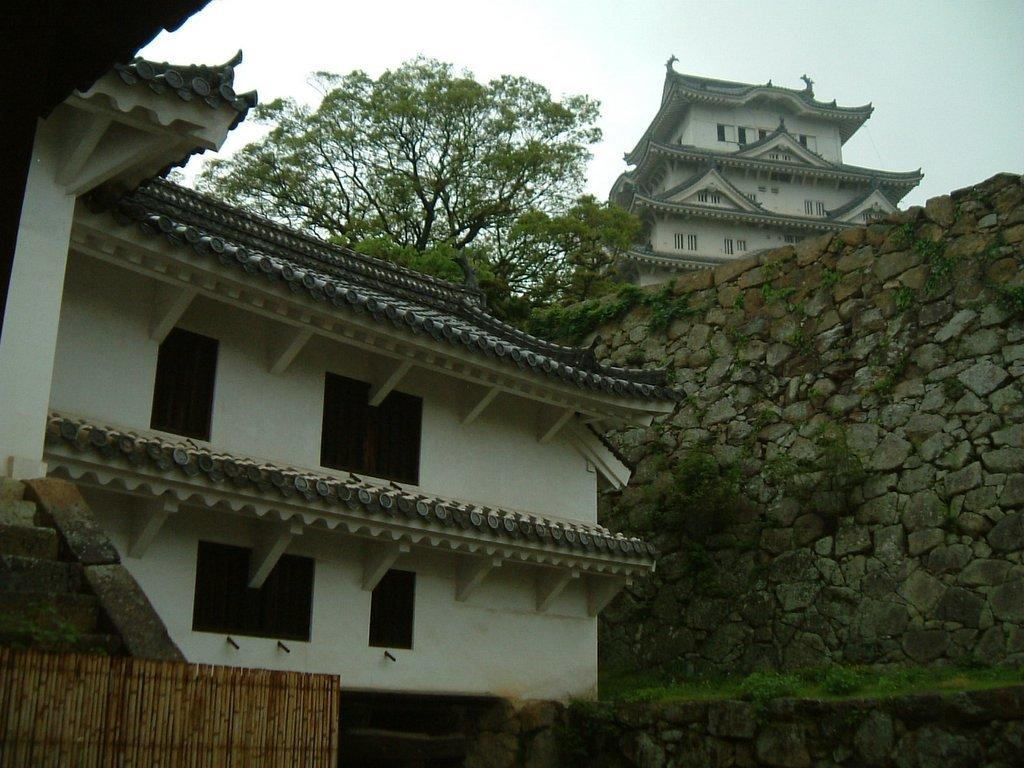What structure is located on the left side of the image? There is a building on the left side of the image. What is beside the building on the left side? There is a wall beside the building on the left side. What is above the wall on the left side? There is a tree above the wall on the left side. What structure is located on the right side of the image? There is a building on the right side of the image. What is visible above the building on the right side? The sky is visible above the building on the right side. Can you tell me how many ministers are present in the image? There is no minister present in the image. What color are the eyes of the tree on the left side of the image? Trees do not have eyes, so this question cannot be answered. 